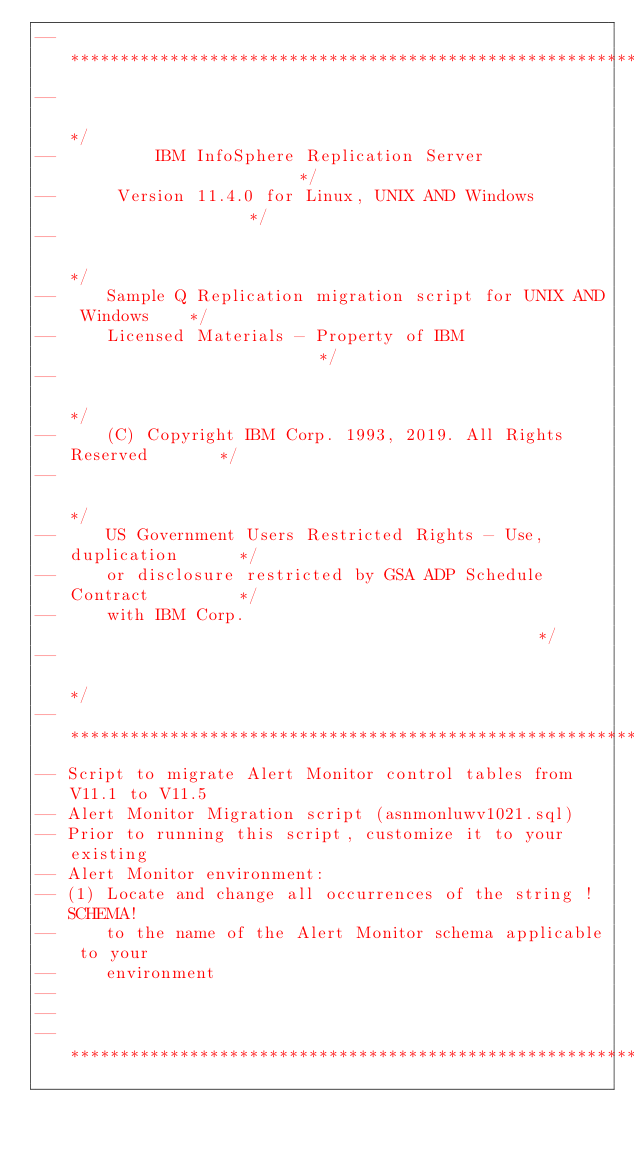Convert code to text. <code><loc_0><loc_0><loc_500><loc_500><_SQL_>--********************************************************************/
--                                                                   */
--          IBM InfoSphere Replication Server                        */
--      Version 11.4.0 for Linux, UNIX AND Windows                   */
--                                                                   */
--     Sample Q Replication migration script for UNIX AND Windows    */
--     Licensed Materials - Property of IBM                          */
--                                                                   */
--     (C) Copyright IBM Corp. 1993, 2019. All Rights Reserved       */
--                                                                   */
--     US Government Users Restricted Rights - Use, duplication      */
--     or disclosure restricted by GSA ADP Schedule Contract         */
--     with IBM Corp.                                                */
--                                                                   */
--********************************************************************/
-- Script to migrate Alert Monitor control tables from V11.1 to V11.5
-- Alert Monitor Migration script (asnmonluwv1021.sql)
-- Prior to running this script, customize it to your existing 
-- Alert Monitor environment:
-- (1) Locate and change all occurrences of the string !SCHEMA! 
--     to the name of the Alert Monitor schema applicable to your
--     environment
--
--
--********************************************************************/
</code> 